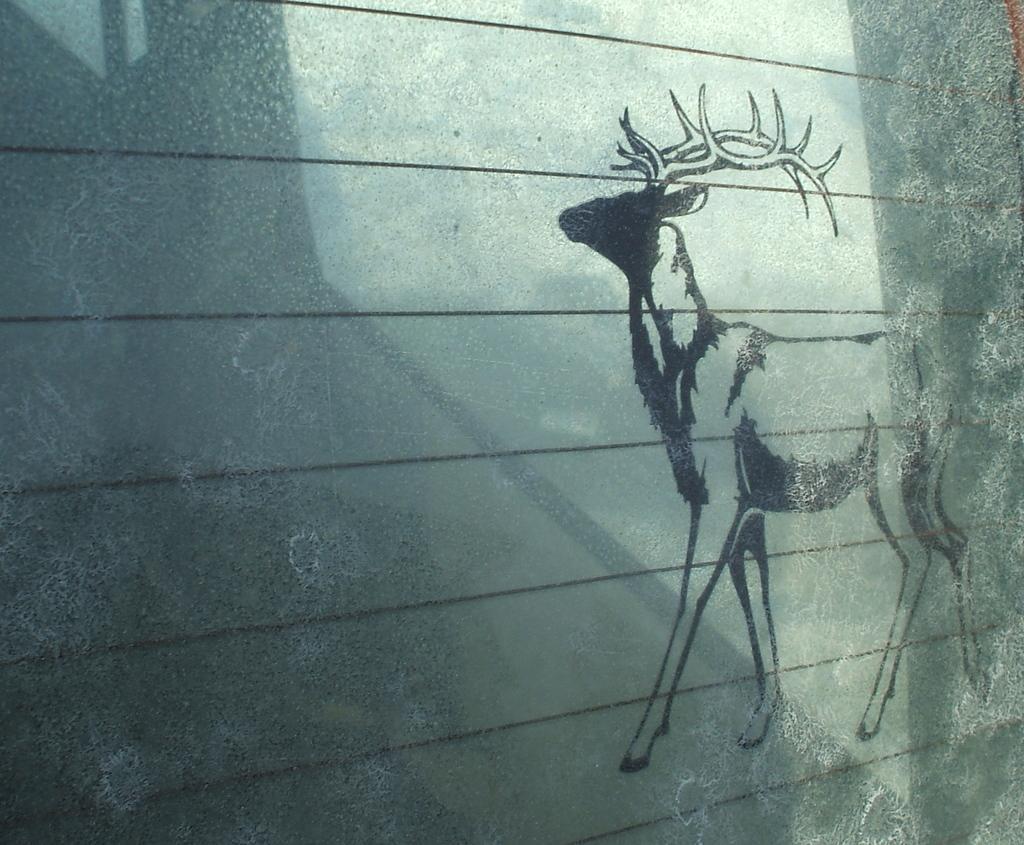Please provide a concise description of this image. In this image I see the wall and I see the art of a deer over here. 